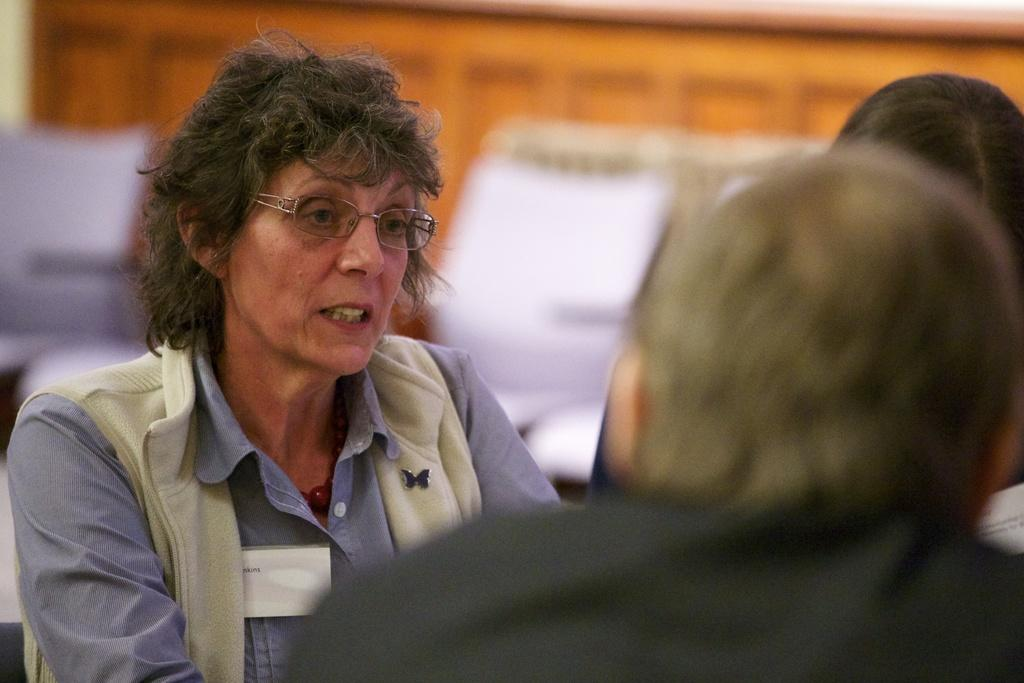How many people are present in the image? There are three people in the image. Can you describe the appearance of one of the individuals? A woman is wearing spectacles. What can be seen in the background of the image? There are objects visible in the background of the image, but they are blurry. What type of texture can be seen on the trains in the image? There are no trains present in the image, so it is not possible to determine the texture of any trains. 